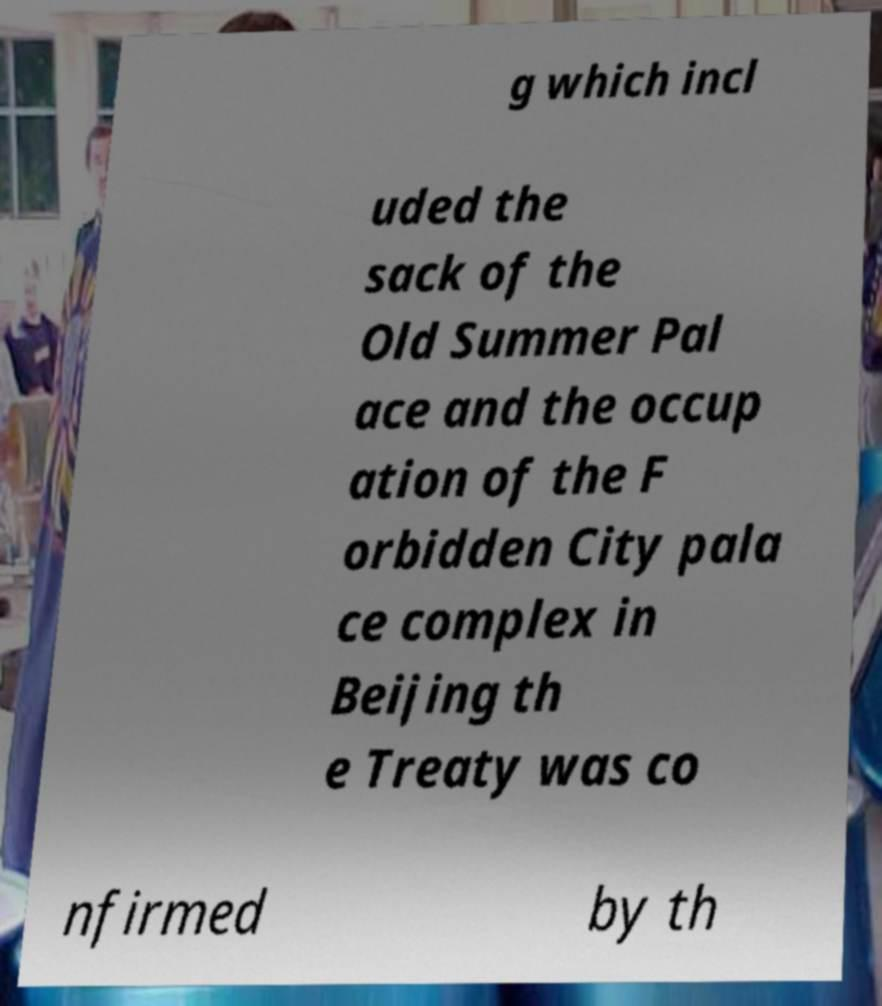What messages or text are displayed in this image? I need them in a readable, typed format. g which incl uded the sack of the Old Summer Pal ace and the occup ation of the F orbidden City pala ce complex in Beijing th e Treaty was co nfirmed by th 